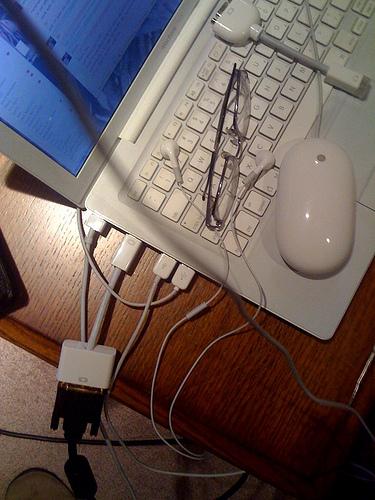Is this person on the internet?
Quick response, please. Yes. Is there a lot of cords plugged into this laptop?
Concise answer only. Yes. How has technology altered human interaction?
Answer briefly. Global communication. 